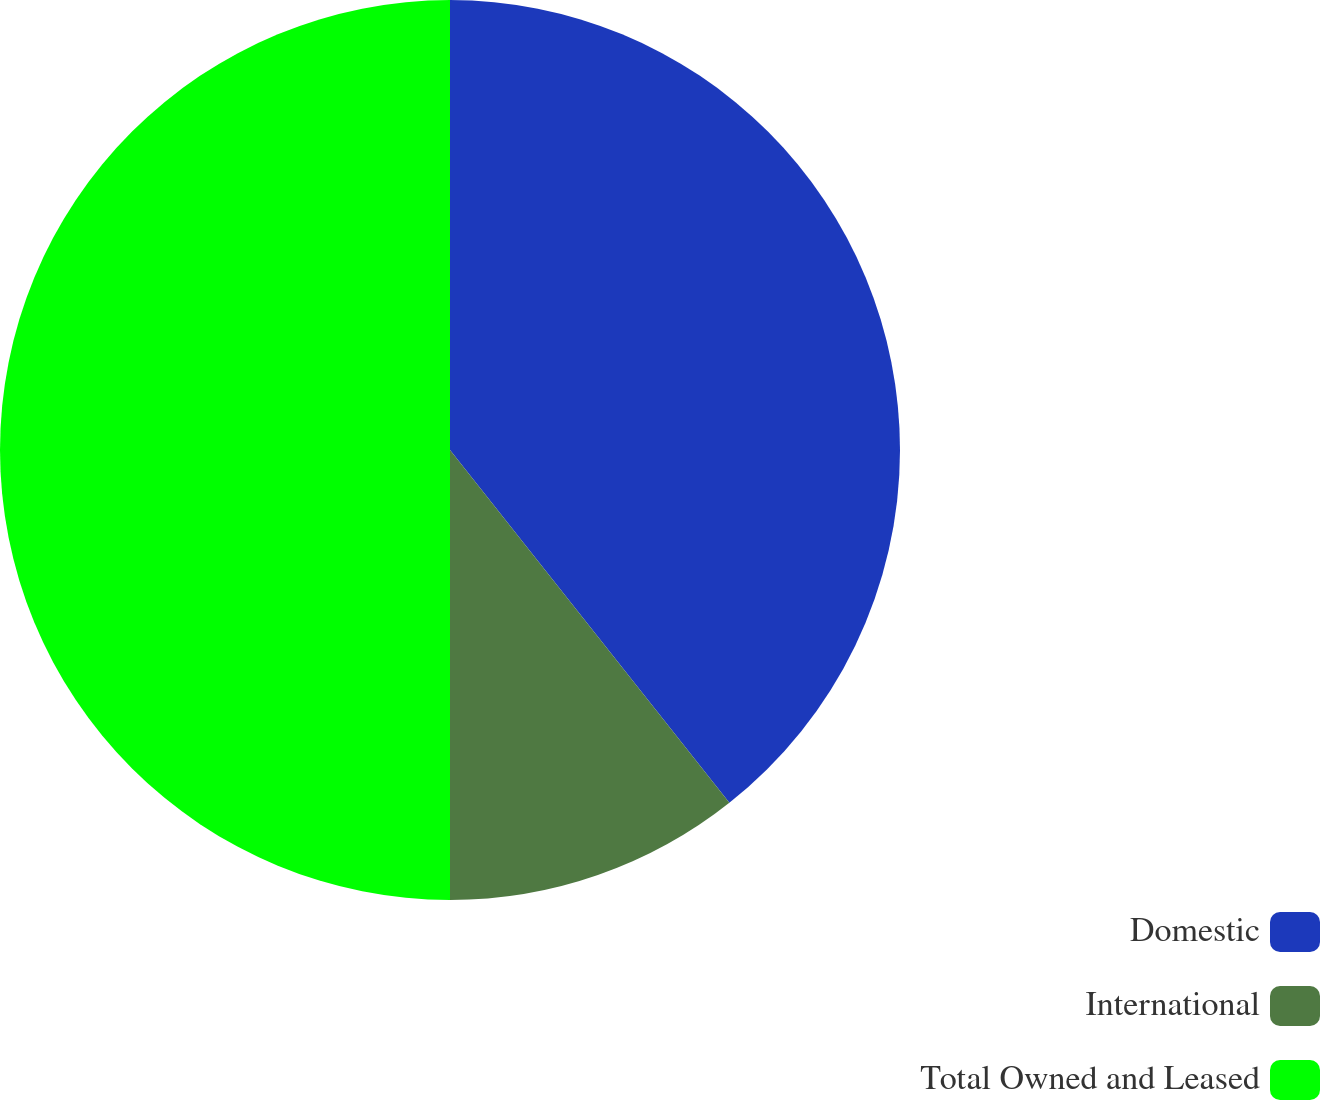Convert chart to OTSL. <chart><loc_0><loc_0><loc_500><loc_500><pie_chart><fcel>Domestic<fcel>International<fcel>Total Owned and Leased<nl><fcel>39.34%<fcel>10.66%<fcel>50.0%<nl></chart> 